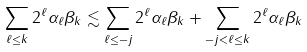Convert formula to latex. <formula><loc_0><loc_0><loc_500><loc_500>\sum _ { \ell \leq k } 2 ^ { \ell } \alpha _ { \ell } \beta _ { k } \lesssim \sum _ { \ell \leq - j } 2 ^ { \ell } \alpha _ { \ell } \beta _ { k } + \sum _ { - j < \ell \leq k } 2 ^ { \ell } \alpha _ { \ell } \beta _ { k }</formula> 